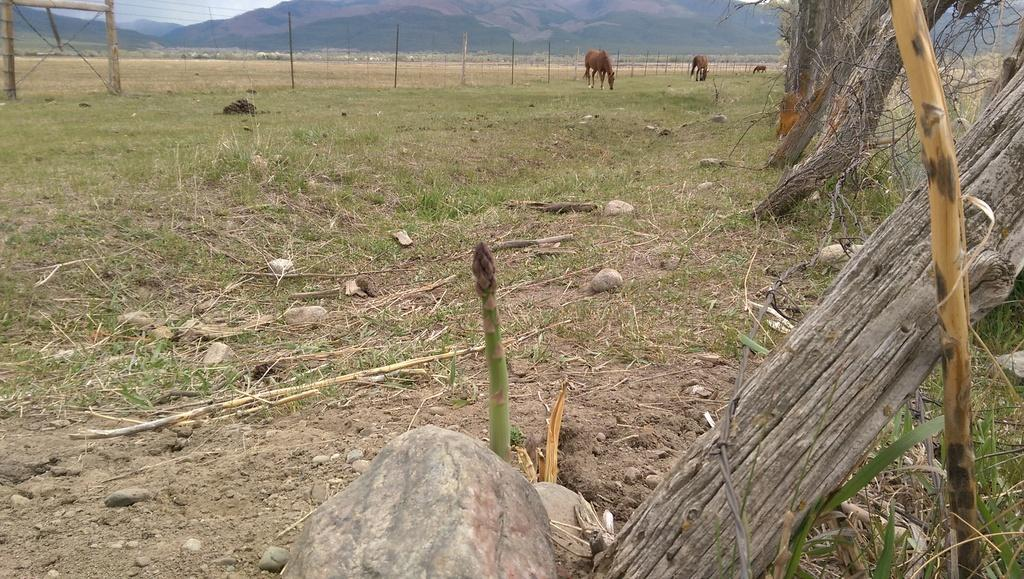What types of living organisms can be seen in the image? There are animals in the image. What objects are present in the image? There are logs and a fence in the image. What can be seen in the background of the image? Hills and the sky are visible in the background of the image. What type of terrain is visible at the bottom of the image? Grass is present at the bottom of the image. Can you tell me how many cents are visible in the image? There are no cents present in the image. What type of ocean can be seen in the image? There is no ocean present in the image. 